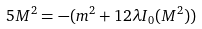<formula> <loc_0><loc_0><loc_500><loc_500>5 M ^ { 2 } = - ( m ^ { 2 } + 1 2 \lambda I _ { 0 } ( M ^ { 2 } ) )</formula> 